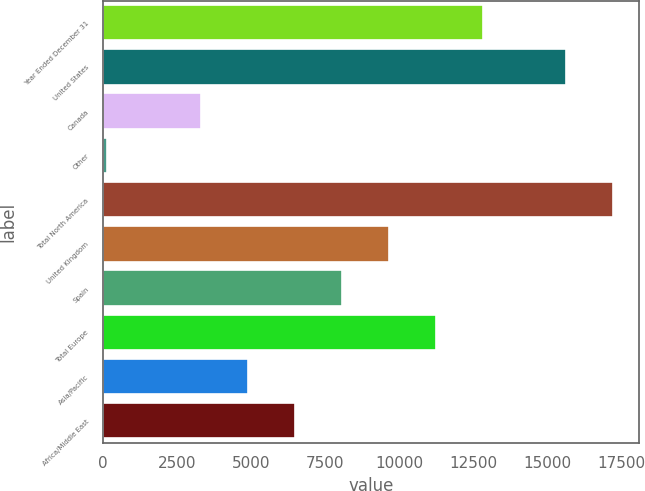Convert chart. <chart><loc_0><loc_0><loc_500><loc_500><bar_chart><fcel>Year Ended December 31<fcel>United States<fcel>Canada<fcel>Other<fcel>Total North America<fcel>United Kingdom<fcel>Spain<fcel>Total Europe<fcel>Asia/Pacific<fcel>Africa/Middle East<nl><fcel>12810<fcel>15631<fcel>3294<fcel>122<fcel>17217<fcel>9638<fcel>8052<fcel>11224<fcel>4880<fcel>6466<nl></chart> 